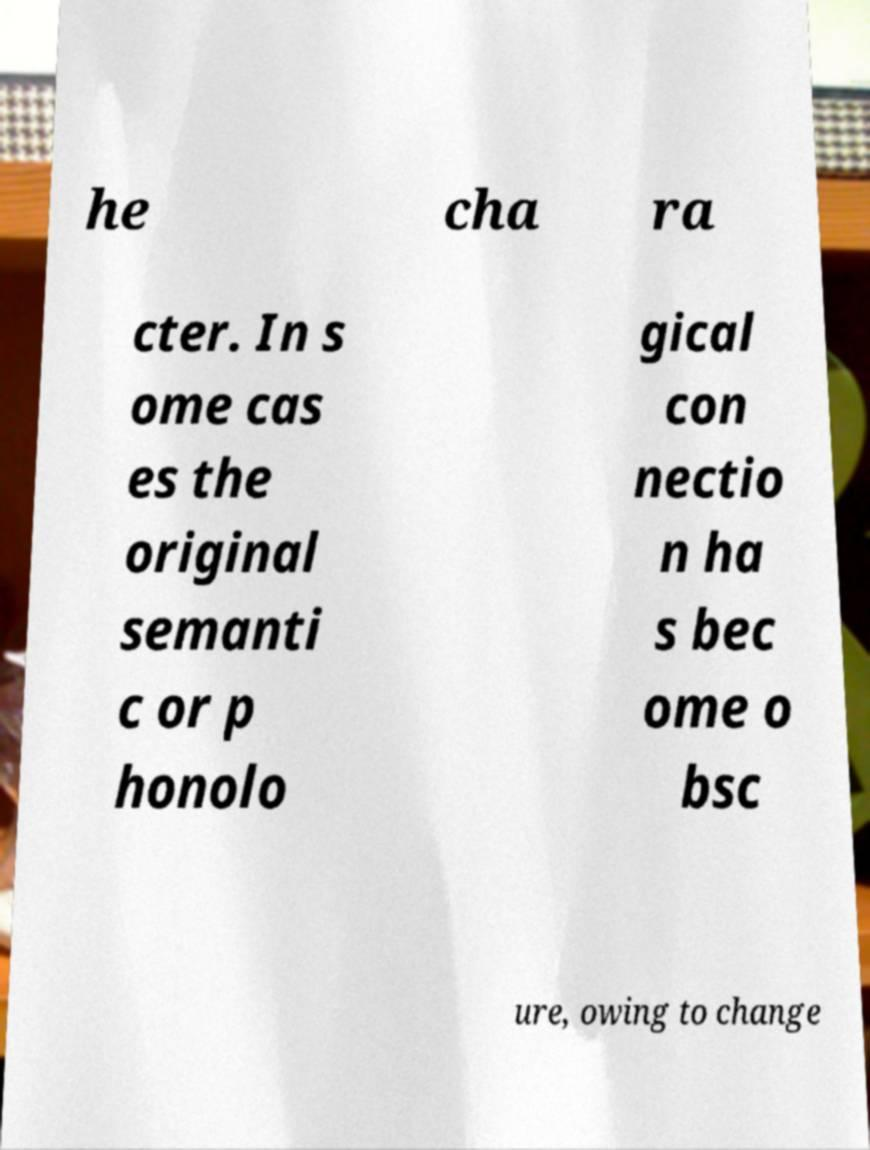Could you assist in decoding the text presented in this image and type it out clearly? he cha ra cter. In s ome cas es the original semanti c or p honolo gical con nectio n ha s bec ome o bsc ure, owing to change 